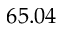Convert formula to latex. <formula><loc_0><loc_0><loc_500><loc_500>6 5 . 0 4</formula> 